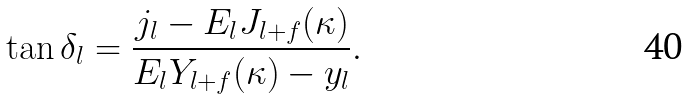Convert formula to latex. <formula><loc_0><loc_0><loc_500><loc_500>\tan \delta _ { l } = \frac { j _ { l } - E _ { l } J _ { l + f } ( \kappa ) } { E _ { l } Y _ { l + f } ( \kappa ) - y _ { l } } .</formula> 